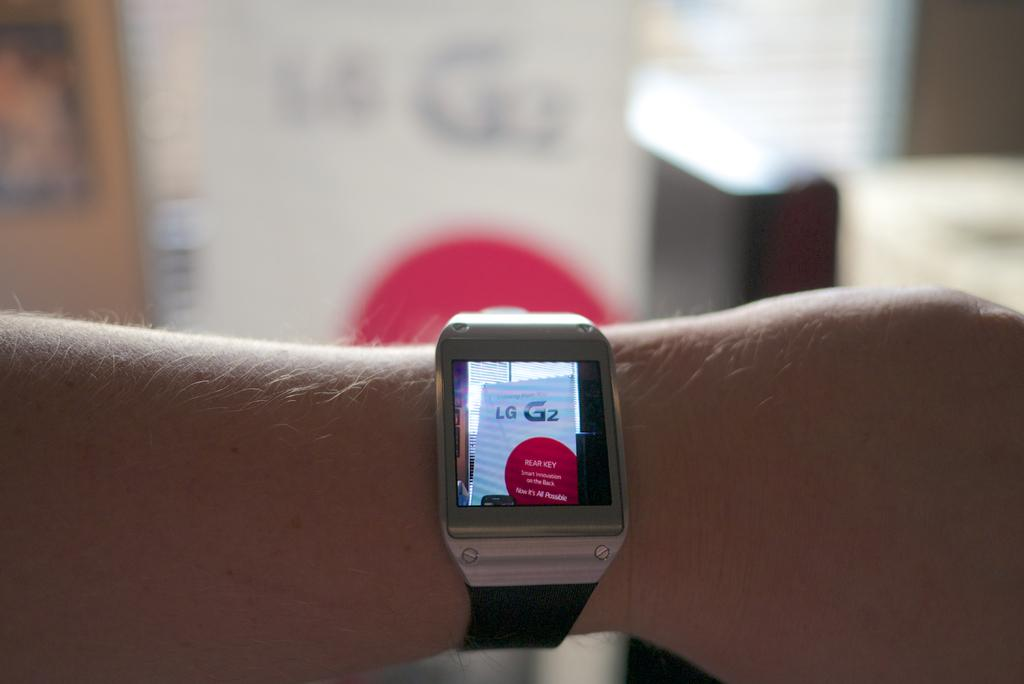Provide a one-sentence caption for the provided image. On an arm a smart watch displays a photo of a store display for LG. 